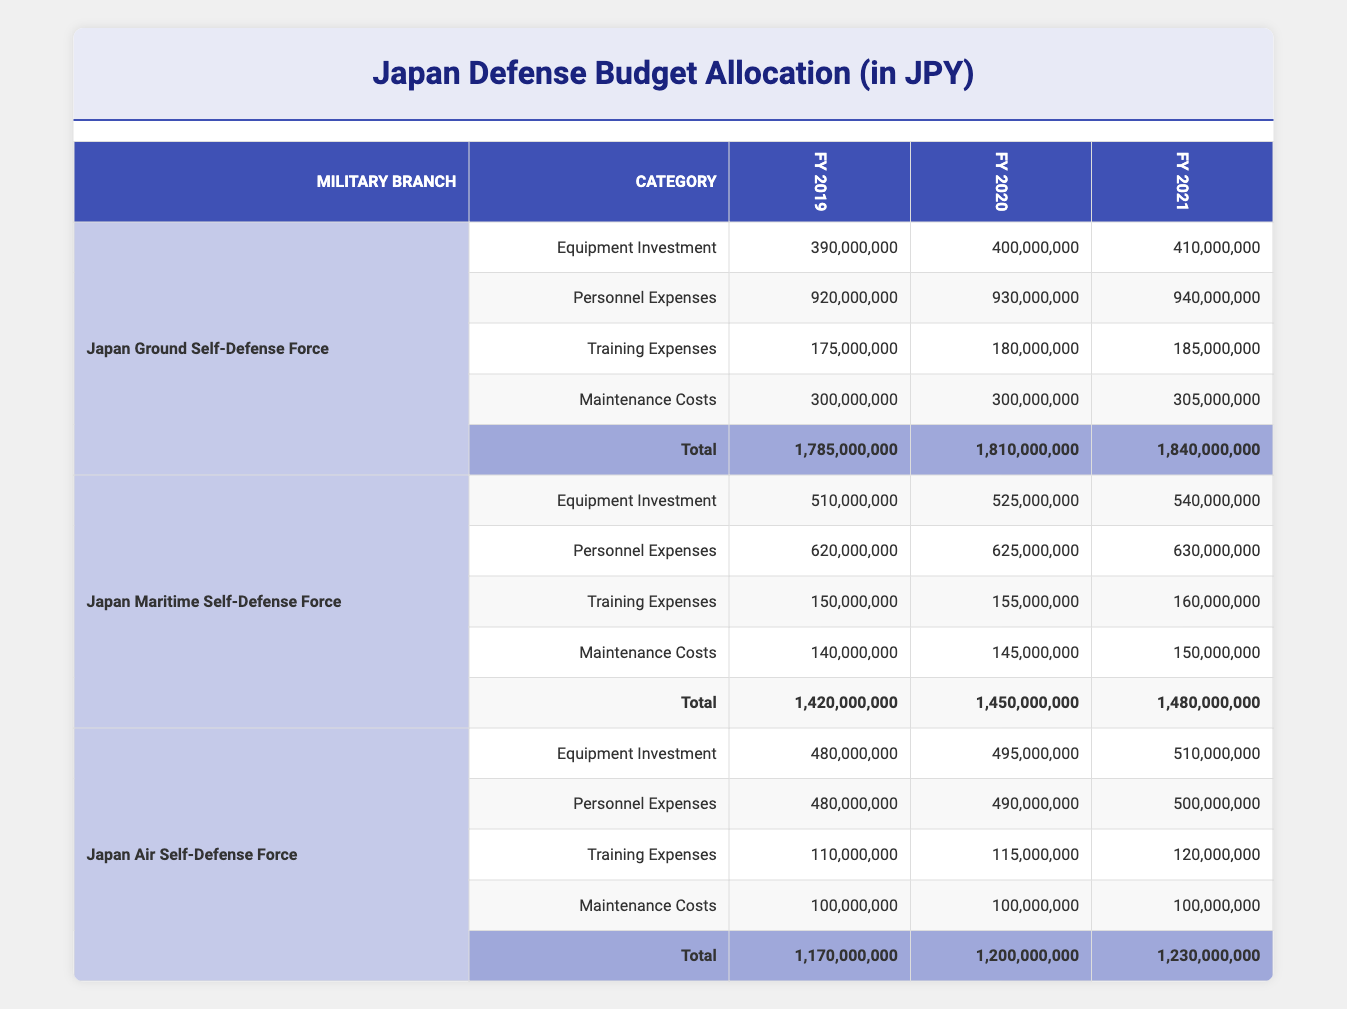What was the total budget allocation for Japan Air Self-Defense Force in fiscal year 2020? The total budget allocation for Japan Air Self-Defense Force in fiscal year 2020 is found in the "Total" row under the "Japan Air Self-Defense Force" branch and for FY 2020 column, which is 1,200,000,000 JPY.
Answer: 1,200,000,000 JPY Which military branch had the highest equipment investment in fiscal year 2021? To find out which military branch had the highest equipment investment in fiscal year 2021, we look at the "Equipment Investment" row for each branch under FY 2021. The values are 410,000,000 for Japan Ground Self-Defense Force, 540,000,000 for Japan Maritime Self-Defense Force, and 510,000,000 for Japan Air Self-Defense Force. Since 540,000,000 is the highest among these, Japan Maritime Self-Defense Force had the highest equipment investment.
Answer: Japan Maritime Self-Defense Force Was the total budget allocation for Japan Ground Self-Defense Force in fiscal year 2020 greater than that of Japan Air Self-Defense Force in the same year? The total budget allocation for Japan Ground Self-Defense Force in fiscal year 2020 is 1,810,000,000 JPY, while for Japan Air Self-Defense Force, it is 1,200,000,000 JPY. Comparing these values, 1,810,000,000 JPY is greater than 1,200,000,000 JPY, confirming the statement is true.
Answer: Yes What is the average training expense for Japan Maritime Self-Defense Force across the three fiscal years? The training expenses for Japan Maritime Self-Defense Force are 150,000,000 in 2019, 155,000,000 in 2020, and 160,000,000 in 2021. The sum of these values is 150,000,000 + 155,000,000 + 160,000,000 = 465,000,000. Dividing by 3 (the number of years), the average is 465,000,000 / 3 = 155,000,000.
Answer: 155,000,000 JPY How much did Japan Air Self-Defense Force allocate for maintenance costs in fiscal year 2021? The maintenance costs for Japan Air Self-Defense Force in fiscal year 2021 are listed in the "Maintenance Costs" row under that branch for FY 2021. The value found there is 100,000,000 JPY.
Answer: 100,000,000 JPY What was the total increase in budget allocation for Japan Ground Self-Defense Force from fiscal year 2019 to 2021? The total budget allocation for Japan Ground Self-Defense Force was 1,785,000,000 in 2019 and 1,840,000,000 in 2021. The increase is calculated as 1,840,000,000 - 1,785,000,000 = 55,000,000 JPY.
Answer: 55,000,000 JPY Did Japan Maritime Self-Defense Force have a decrease in total budget allocation from fiscal year 2019 to 2021? The total budget allocation for Japan Maritime Self-Defense Force for fiscal years 2019 and 2021 are 1,420,000,000 and 1,480,000,000 respectively. To check for a decrease, we compare these two values: 1,480,000,000 is greater than 1,420,000,000, indicating there was no decrease.
Answer: No What are the total personnel expenses for Japan Ground Self-Defense Force across the three fiscal years? The personnel expenses for Japan Ground Self-Defense Force are 920,000,000 in 2019, 930,000,000 in 2020, and 940,000,000 in 2021. Adding these together gives 920,000,000 + 930,000,000 + 940,000,000 = 2,790,000,000 JPY.
Answer: 2,790,000,000 JPY 